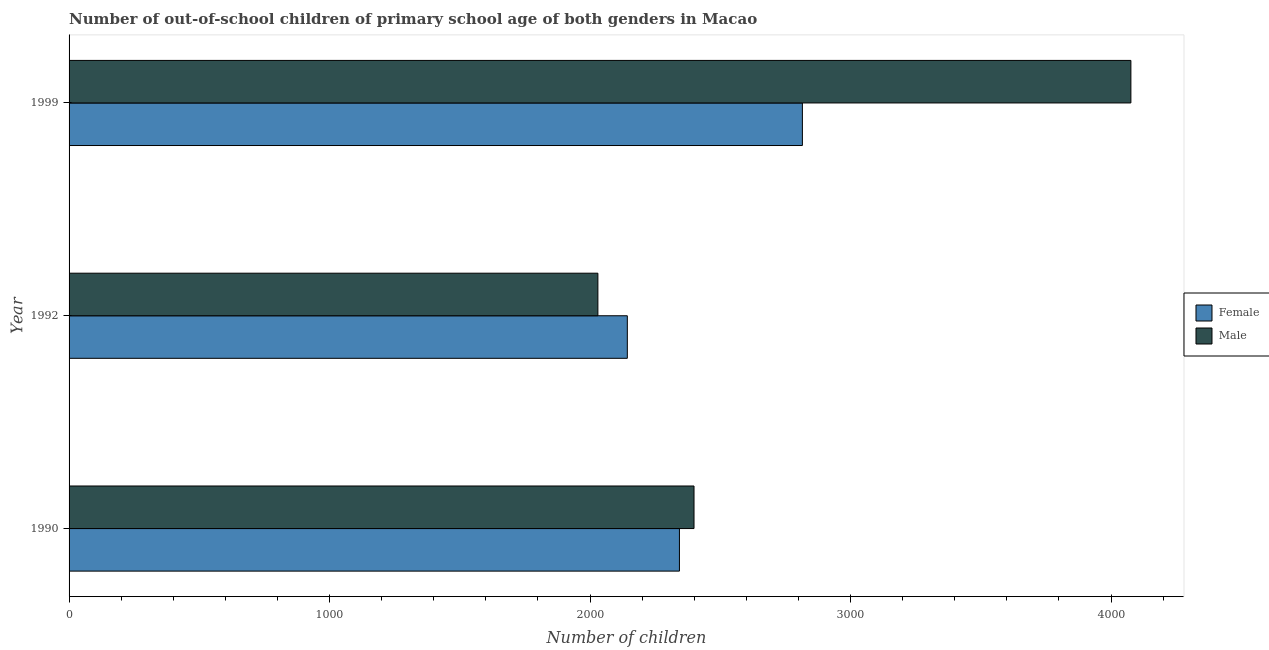How many groups of bars are there?
Give a very brief answer. 3. Are the number of bars per tick equal to the number of legend labels?
Provide a succinct answer. Yes. How many bars are there on the 1st tick from the top?
Provide a short and direct response. 2. How many bars are there on the 1st tick from the bottom?
Ensure brevity in your answer.  2. What is the label of the 1st group of bars from the top?
Your answer should be compact. 1999. In how many cases, is the number of bars for a given year not equal to the number of legend labels?
Provide a short and direct response. 0. What is the number of female out-of-school students in 1990?
Provide a succinct answer. 2343. Across all years, what is the maximum number of male out-of-school students?
Make the answer very short. 4076. Across all years, what is the minimum number of female out-of-school students?
Provide a short and direct response. 2143. In which year was the number of male out-of-school students maximum?
Provide a short and direct response. 1999. In which year was the number of female out-of-school students minimum?
Provide a short and direct response. 1992. What is the total number of male out-of-school students in the graph?
Keep it short and to the point. 8505. What is the difference between the number of male out-of-school students in 1992 and that in 1999?
Your answer should be very brief. -2046. What is the difference between the number of male out-of-school students in 1992 and the number of female out-of-school students in 1990?
Keep it short and to the point. -313. What is the average number of male out-of-school students per year?
Give a very brief answer. 2835. In the year 1999, what is the difference between the number of female out-of-school students and number of male out-of-school students?
Your response must be concise. -1261. In how many years, is the number of male out-of-school students greater than 2000 ?
Make the answer very short. 3. What is the ratio of the number of female out-of-school students in 1990 to that in 1999?
Your answer should be compact. 0.83. Is the number of female out-of-school students in 1990 less than that in 1992?
Provide a short and direct response. No. Is the difference between the number of male out-of-school students in 1992 and 1999 greater than the difference between the number of female out-of-school students in 1992 and 1999?
Your response must be concise. No. What is the difference between the highest and the second highest number of female out-of-school students?
Your response must be concise. 472. What is the difference between the highest and the lowest number of female out-of-school students?
Keep it short and to the point. 672. Is the sum of the number of female out-of-school students in 1990 and 1999 greater than the maximum number of male out-of-school students across all years?
Your answer should be very brief. Yes. What does the 2nd bar from the top in 1992 represents?
Give a very brief answer. Female. How many years are there in the graph?
Keep it short and to the point. 3. Does the graph contain any zero values?
Your answer should be very brief. No. How many legend labels are there?
Give a very brief answer. 2. How are the legend labels stacked?
Keep it short and to the point. Vertical. What is the title of the graph?
Your answer should be compact. Number of out-of-school children of primary school age of both genders in Macao. What is the label or title of the X-axis?
Provide a succinct answer. Number of children. What is the Number of children in Female in 1990?
Ensure brevity in your answer.  2343. What is the Number of children of Male in 1990?
Your answer should be compact. 2399. What is the Number of children in Female in 1992?
Give a very brief answer. 2143. What is the Number of children of Male in 1992?
Your answer should be compact. 2030. What is the Number of children of Female in 1999?
Your response must be concise. 2815. What is the Number of children of Male in 1999?
Keep it short and to the point. 4076. Across all years, what is the maximum Number of children of Female?
Your answer should be compact. 2815. Across all years, what is the maximum Number of children of Male?
Provide a succinct answer. 4076. Across all years, what is the minimum Number of children in Female?
Offer a terse response. 2143. Across all years, what is the minimum Number of children in Male?
Keep it short and to the point. 2030. What is the total Number of children in Female in the graph?
Make the answer very short. 7301. What is the total Number of children in Male in the graph?
Make the answer very short. 8505. What is the difference between the Number of children of Male in 1990 and that in 1992?
Provide a short and direct response. 369. What is the difference between the Number of children in Female in 1990 and that in 1999?
Make the answer very short. -472. What is the difference between the Number of children in Male in 1990 and that in 1999?
Make the answer very short. -1677. What is the difference between the Number of children in Female in 1992 and that in 1999?
Provide a short and direct response. -672. What is the difference between the Number of children of Male in 1992 and that in 1999?
Offer a very short reply. -2046. What is the difference between the Number of children of Female in 1990 and the Number of children of Male in 1992?
Your answer should be very brief. 313. What is the difference between the Number of children of Female in 1990 and the Number of children of Male in 1999?
Your answer should be compact. -1733. What is the difference between the Number of children in Female in 1992 and the Number of children in Male in 1999?
Your response must be concise. -1933. What is the average Number of children in Female per year?
Provide a succinct answer. 2433.67. What is the average Number of children of Male per year?
Make the answer very short. 2835. In the year 1990, what is the difference between the Number of children of Female and Number of children of Male?
Ensure brevity in your answer.  -56. In the year 1992, what is the difference between the Number of children of Female and Number of children of Male?
Provide a short and direct response. 113. In the year 1999, what is the difference between the Number of children in Female and Number of children in Male?
Your answer should be compact. -1261. What is the ratio of the Number of children of Female in 1990 to that in 1992?
Offer a very short reply. 1.09. What is the ratio of the Number of children of Male in 1990 to that in 1992?
Provide a short and direct response. 1.18. What is the ratio of the Number of children in Female in 1990 to that in 1999?
Provide a succinct answer. 0.83. What is the ratio of the Number of children in Male in 1990 to that in 1999?
Provide a short and direct response. 0.59. What is the ratio of the Number of children in Female in 1992 to that in 1999?
Ensure brevity in your answer.  0.76. What is the ratio of the Number of children in Male in 1992 to that in 1999?
Your answer should be compact. 0.5. What is the difference between the highest and the second highest Number of children in Female?
Give a very brief answer. 472. What is the difference between the highest and the second highest Number of children in Male?
Offer a very short reply. 1677. What is the difference between the highest and the lowest Number of children in Female?
Provide a short and direct response. 672. What is the difference between the highest and the lowest Number of children of Male?
Give a very brief answer. 2046. 